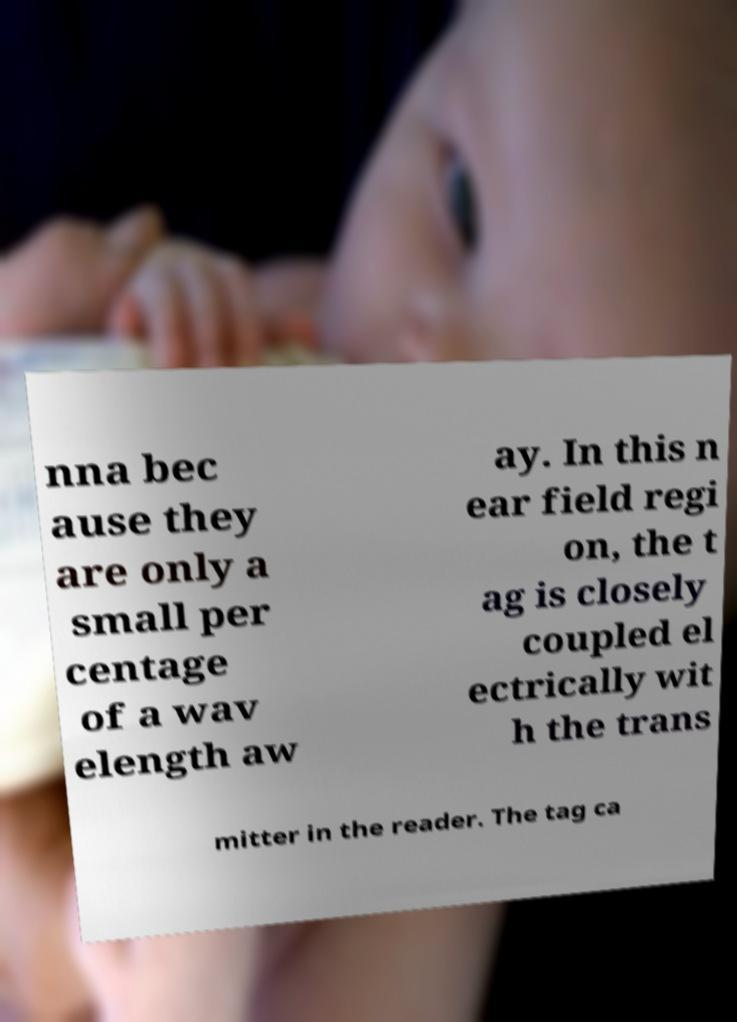Can you accurately transcribe the text from the provided image for me? nna bec ause they are only a small per centage of a wav elength aw ay. In this n ear field regi on, the t ag is closely coupled el ectrically wit h the trans mitter in the reader. The tag ca 